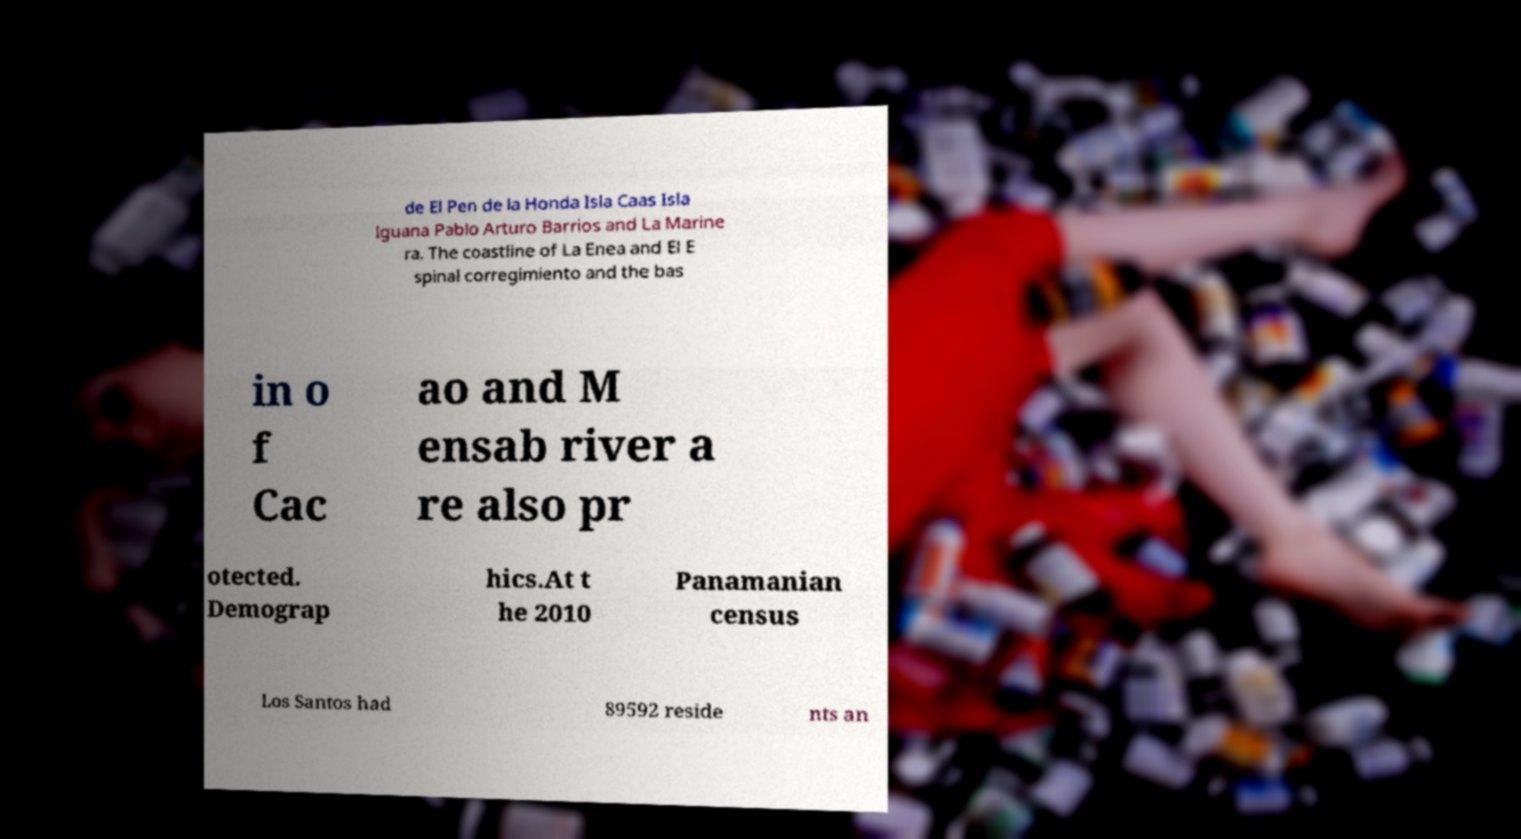Can you accurately transcribe the text from the provided image for me? de El Pen de la Honda Isla Caas Isla Iguana Pablo Arturo Barrios and La Marine ra. The coastline of La Enea and El E spinal corregimiento and the bas in o f Cac ao and M ensab river a re also pr otected. Demograp hics.At t he 2010 Panamanian census Los Santos had 89592 reside nts an 